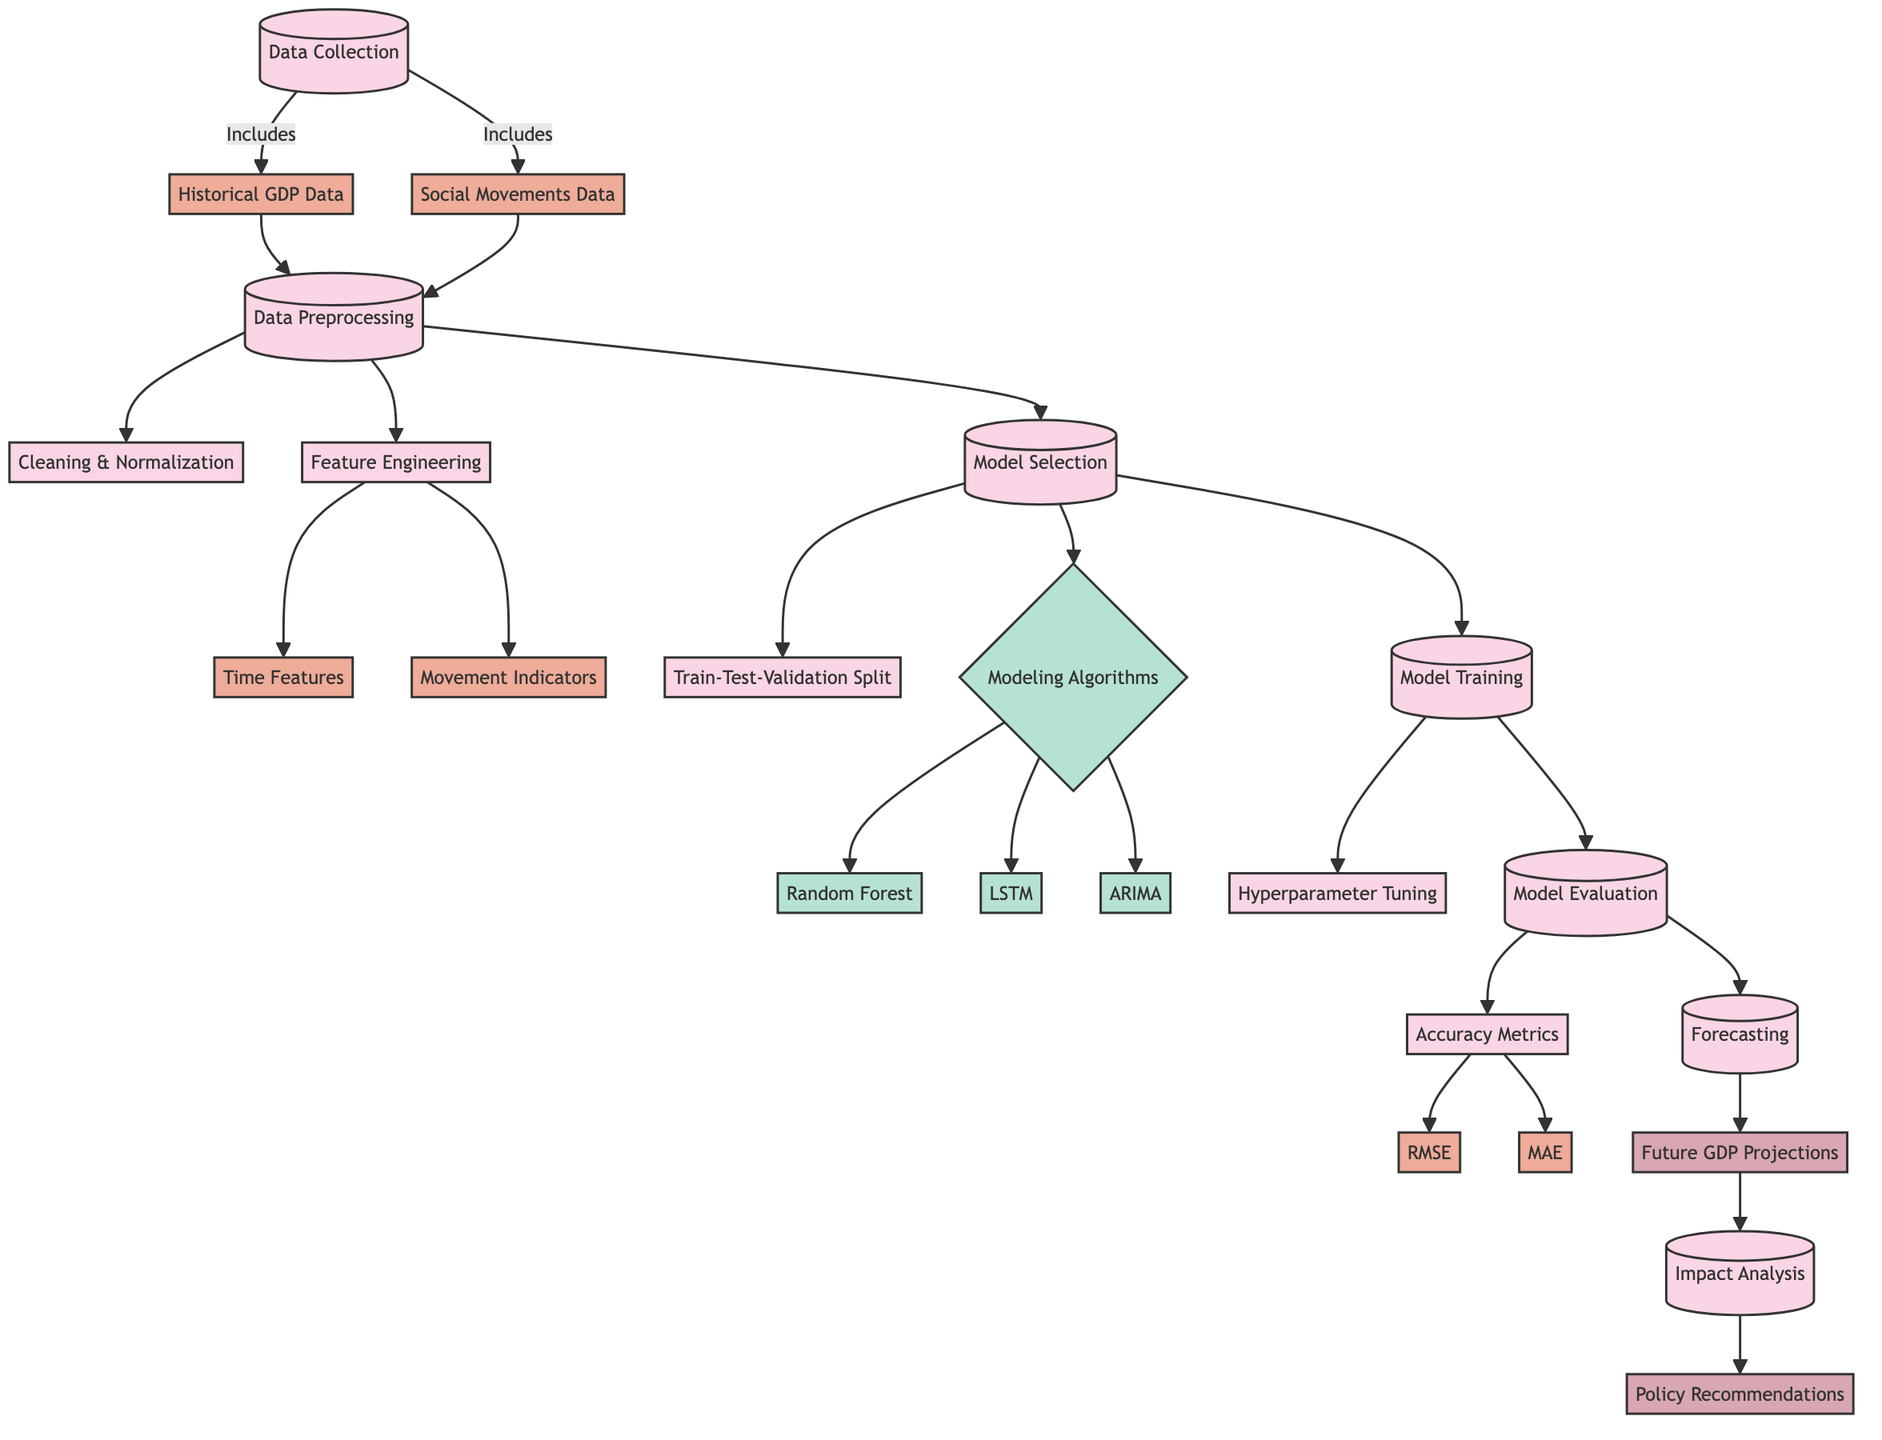What are the main processes outlined in this diagram? The diagram includes several main processes: Data Collection, Data Preprocessing, Model Selection, Model Training, Model Evaluation, Forecasting, and Impact Analysis. These processes are the primary steps involved in the analysis.
Answer: Data Collection, Data Preprocessing, Model Selection, Model Training, Model Evaluation, Forecasting, Impact Analysis How many algorithms are represented in the model selection process? The diagram shows three algorithms listed under modeling algorithms: Random Forest, LSTM, and ARIMA. This indicates that there are multiple options available for modeling.
Answer: Three Which nodes are connected to the forecasting process? The forecasting process is connected to the model evaluation process and leads to the future GDP projections node. The connection indicates that forecasting relies on the results from model evaluation to generate its outputs.
Answer: Model Evaluation, Future GDP Projections What is the purpose of the cleaning and normalization process? The cleaning and normalization process is part of data preprocessing, specifically aimed at preparing the collected data for analysis by ensuring that it is free from errors and in a consistent format. It is essential for improving data quality before further analysis.
Answer: Data Preprocessing Which process comes immediately after model evaluation? The process that follows model evaluation is forecasting. This indicates that once the model has been evaluated, the next step is to make predictions about future GDP based on the evaluation outcomes.
Answer: Forecasting What output is generated after forecasting? The output generated after forecasting is the future GDP projections, which are the final predictions made based on the trained model and the historical data analyzed. This output can provide insights into expected GDP changes based on historical trends and social movements.
Answer: Future GDP Projections What are the accuracy metrics used in the model evaluation? The accuracy metrics represented in the diagram include RMSE and MAE. These metrics are used to assess the performance of the models during the evaluation phase.
Answer: RMSE, MAE Which two subprocesses follow data preprocessing? The subprocesses following data preprocessing are Cleaning & Normalization and Feature Engineering. These steps are critical in the preparation of data to ensure it is suitable for model training.
Answer: Cleaning & Normalization, Feature Engineering Where does the path of impact analysis lead? The path from impact analysis leads to policy recommendations, indicating that the analysis of the economic consequences of the modeled data culminates in making suggestions for policy based on the predicted impacts of social movements on GDP.
Answer: Policy Recommendations 